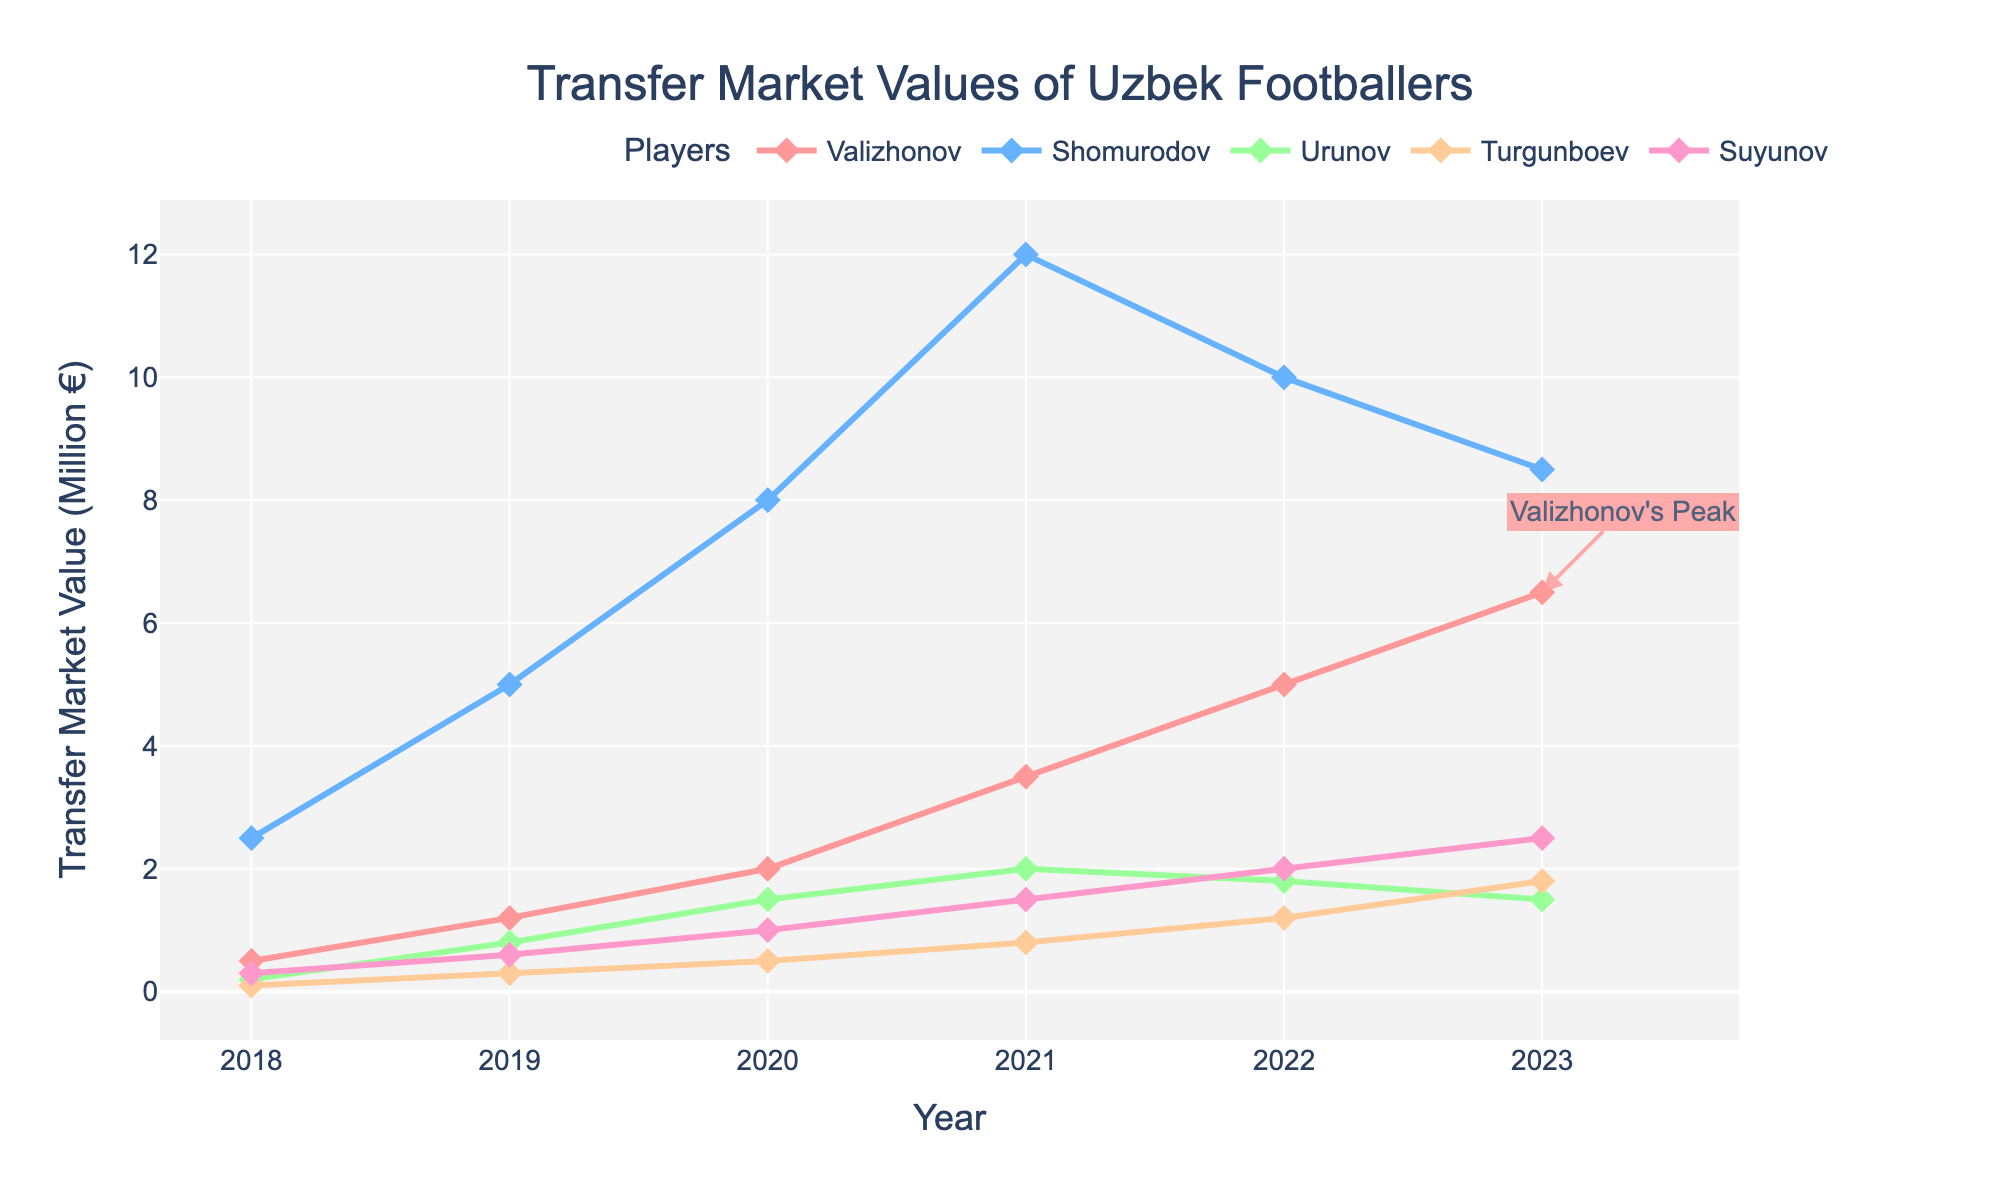what year did Valizhonov reach his peak transfer market value? Valizhonov reached his peak transfer market value in 2023 as indicated by the annotation "Valizhonov's Peak" at that year in the figure.
Answer: 2023 How did Shomurodov's transfer market value change from 2018 to 2023? To determine Shomurodov's change, subtract his 2018 value from his 2023 value: 8.5 - 2.5 = 6.0. However, notice that Shomurodov's transfer market value actually decreased from a peak, reaching a value of 8.5 in 2023 after peaking in 2021 at 12.0.
Answer: It decreased overall What was the average transfer market value of Turgunboev over the recorded years? To find the average, add Turgunboev's values from 2018 to 2023, then divide by the number of years: (0.1 + 0.3 + 0.5 + 0.8 + 1.2 + 1.8) / 6 = 4.7 / 6 ≈ 0.78.
Answer: 0.78 Compare the trends of Suyunov and Urunov over the years. Suyunov's values consistently increased from 0.3 to 2.5, while Urunov increased until 2021 (peaking at 2.0) but then decreased to 1.5 in 2023. This shows Suyunov's values having a steady rise, and Urunov peaking and then declining.
Answer: Suyunov consistently increased, Urunov peaked and then declined Which player had the lowest transfer market value in 2020, and what was it? In 2020, Turgunboev had the lowest value of 0.5 as seen in the figure where his value line is positioned lowest compared to the other players.
Answer: Turgunboev with 0.5 What was the difference in transfer market value between Valizhonov and Shomurodov in 2021? Subtract Shomurodov's value from Valizhonov’s value in 2021: 3.5 - 12.0 = -8.5. This indicates that Shomurodov was 8.5 higher than Valizhonov.
Answer: -8.5 During which year did Urunov experience the highest market value, and how much was it? Urunov experienced his highest market value in 2021 as seen by the peak at that year, with a value of 2.0.
Answer: 2021 with 2.0 Did Turgunboev ever surpass Urunov in market value? If so, when? Yes, in 2023, Turgunboev had a higher market value (1.8) compared to Urunov (1.5), as observed by comparing the position of their respective data points in the figure.
Answer: Yes, in 2023 What is the overall trend of transfer market values for Suyunov from 2018 to 2023? The trend for Suyunov is a steady increase from 0.3 in 2018 to 2.5 in 2023 as indicated by the continuous upward slope of his line in the figure.
Answer: Steady increase 